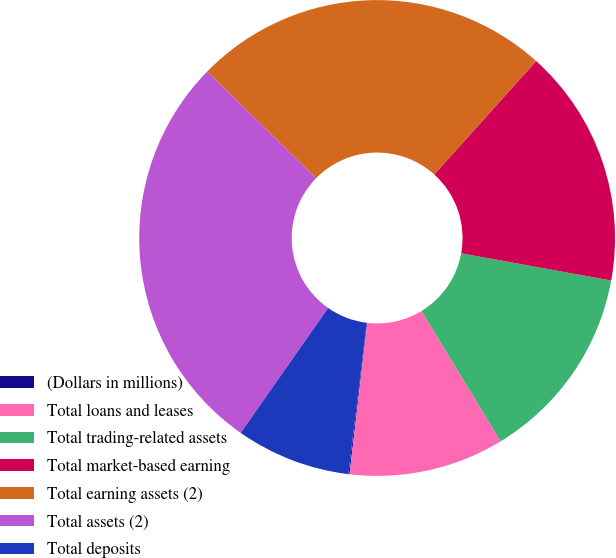Convert chart. <chart><loc_0><loc_0><loc_500><loc_500><pie_chart><fcel>(Dollars in millions)<fcel>Total loans and leases<fcel>Total trading-related assets<fcel>Total market-based earning<fcel>Total earning assets (2)<fcel>Total assets (2)<fcel>Total deposits<nl><fcel>0.08%<fcel>10.54%<fcel>13.45%<fcel>16.21%<fcel>24.32%<fcel>27.61%<fcel>7.79%<nl></chart> 